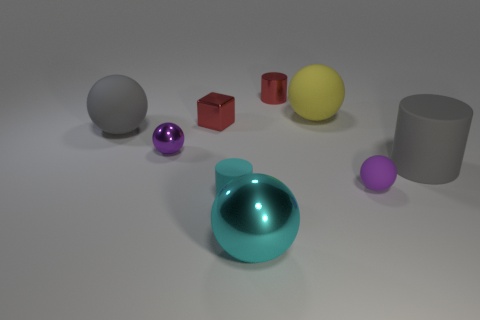Subtract all yellow blocks. Subtract all blue cylinders. How many blocks are left? 1 Subtract all red blocks. How many brown balls are left? 0 Add 1 small grays. How many big objects exist? 0 Subtract all small red shiny cylinders. Subtract all small purple spheres. How many objects are left? 6 Add 3 red blocks. How many red blocks are left? 4 Add 8 large green shiny balls. How many large green shiny balls exist? 8 Add 1 tiny red cubes. How many objects exist? 10 Subtract all red cylinders. How many cylinders are left? 2 Subtract all large rubber balls. How many balls are left? 3 Subtract 1 purple balls. How many objects are left? 8 